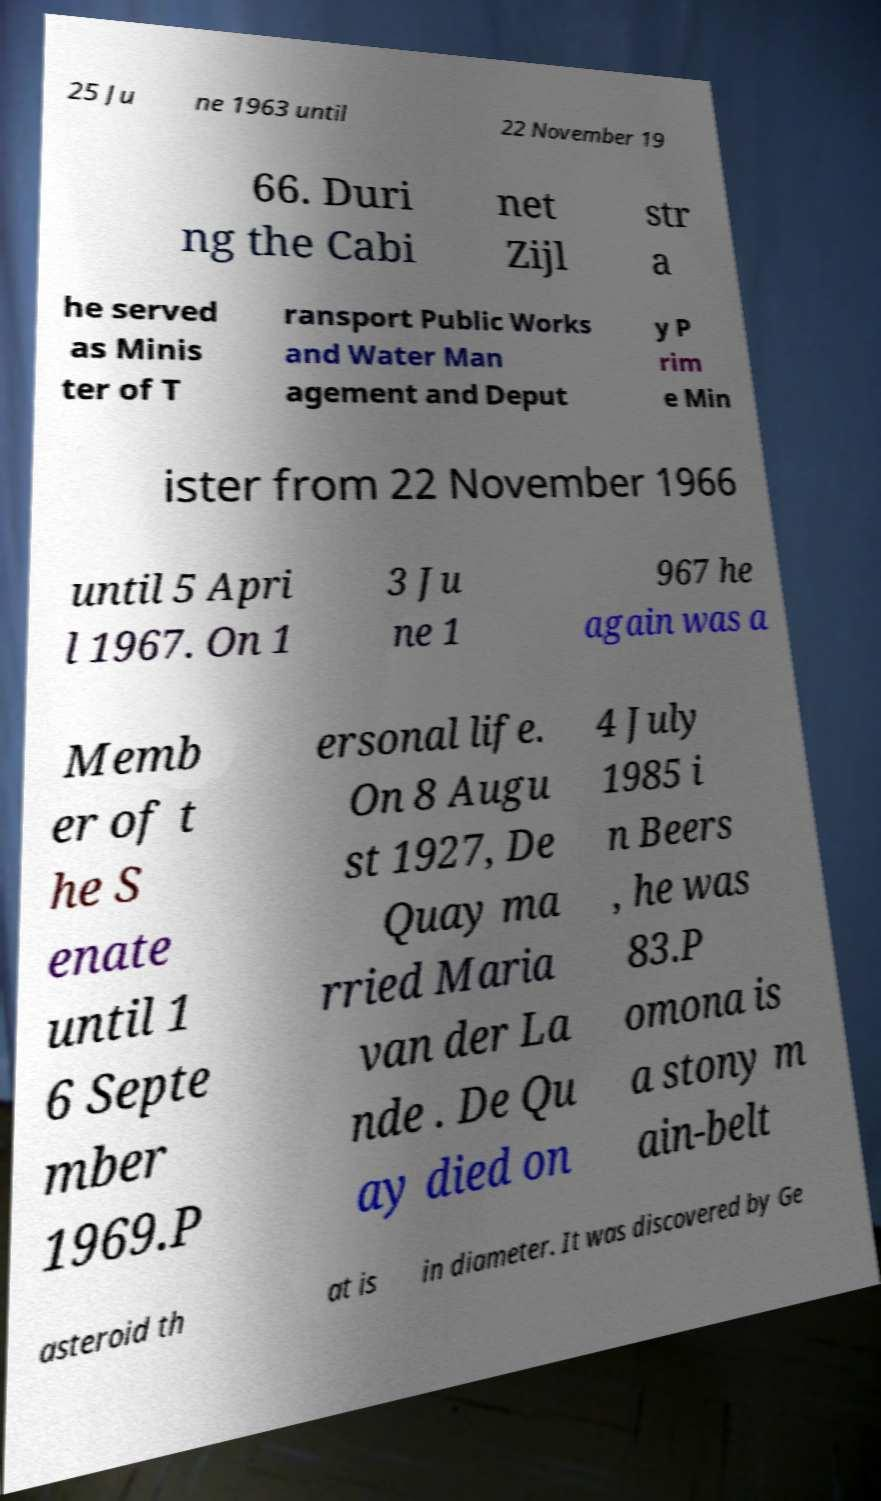There's text embedded in this image that I need extracted. Can you transcribe it verbatim? 25 Ju ne 1963 until 22 November 19 66. Duri ng the Cabi net Zijl str a he served as Minis ter of T ransport Public Works and Water Man agement and Deput y P rim e Min ister from 22 November 1966 until 5 Apri l 1967. On 1 3 Ju ne 1 967 he again was a Memb er of t he S enate until 1 6 Septe mber 1969.P ersonal life. On 8 Augu st 1927, De Quay ma rried Maria van der La nde . De Qu ay died on 4 July 1985 i n Beers , he was 83.P omona is a stony m ain-belt asteroid th at is in diameter. It was discovered by Ge 